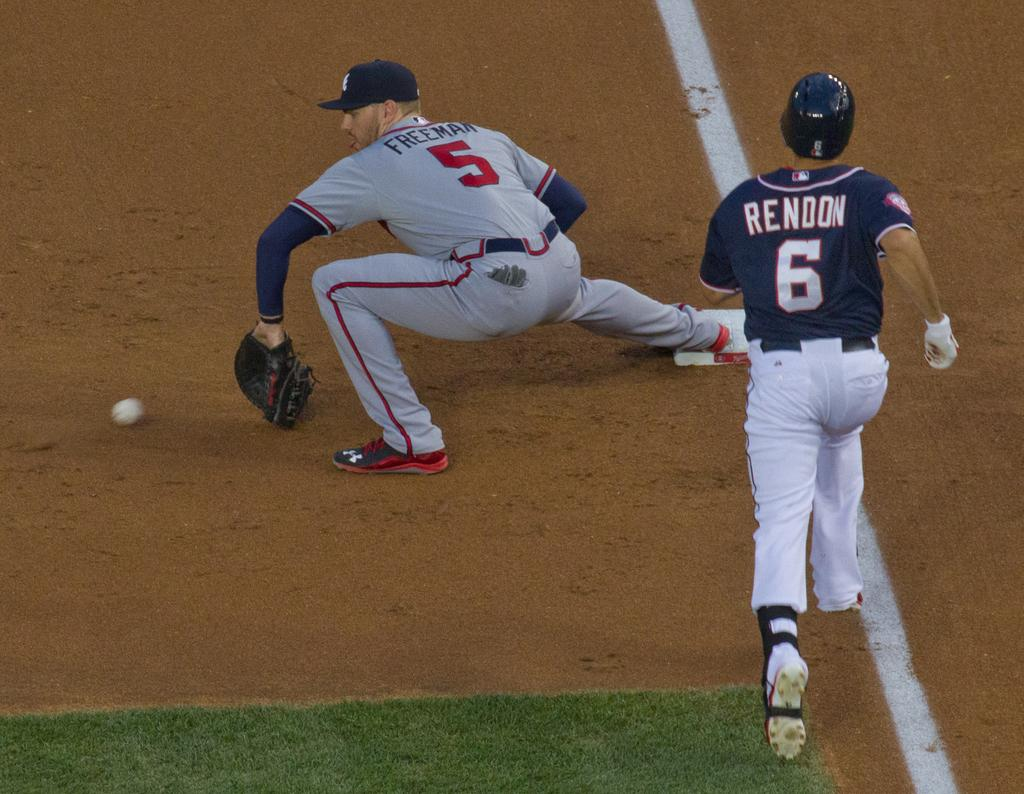Provide a one-sentence caption for the provided image. Rendon, wearing the number 6 jersey, is on the run. 